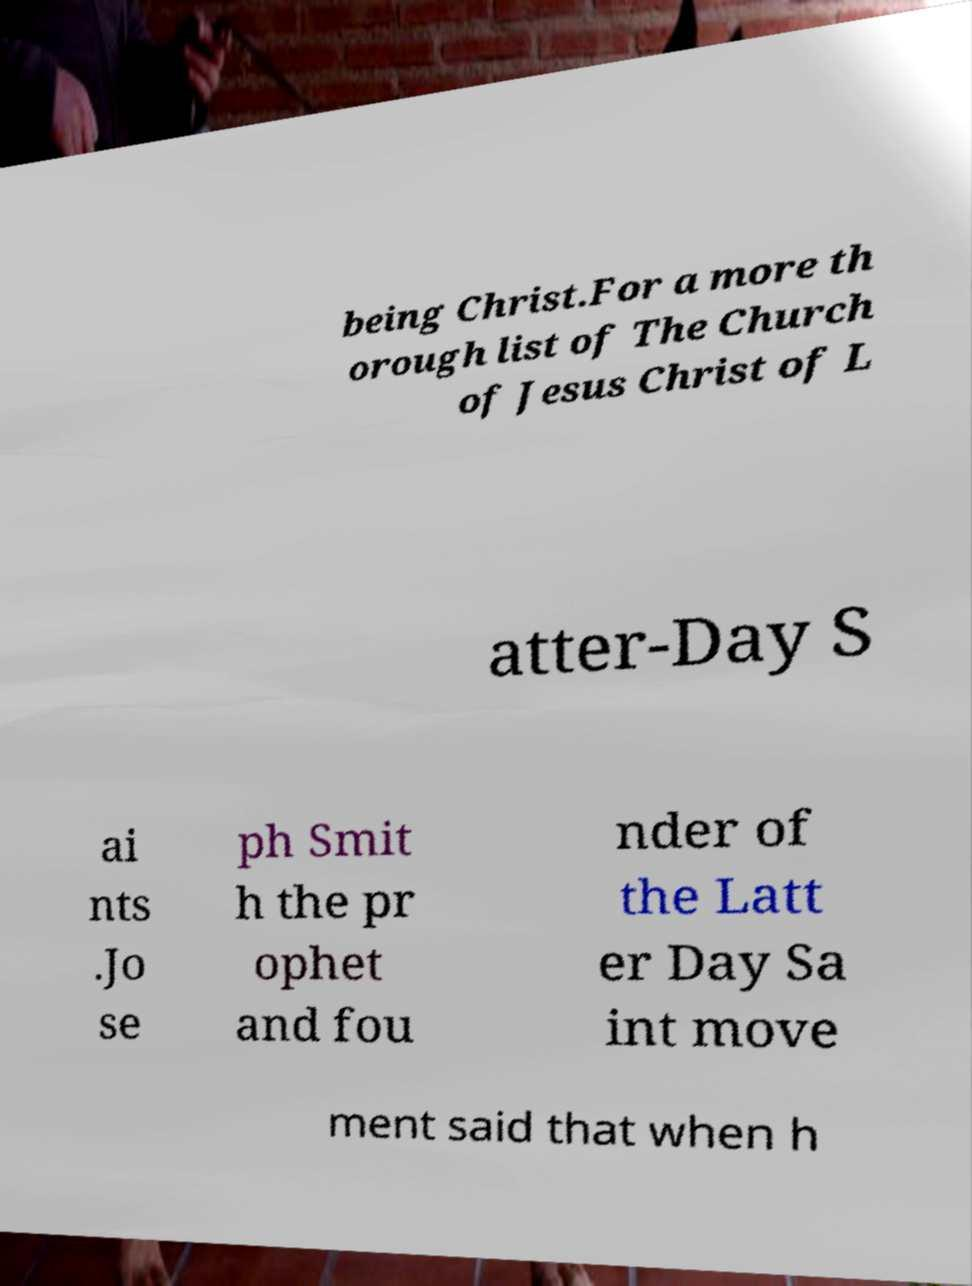Could you extract and type out the text from this image? being Christ.For a more th orough list of The Church of Jesus Christ of L atter-Day S ai nts .Jo se ph Smit h the pr ophet and fou nder of the Latt er Day Sa int move ment said that when h 